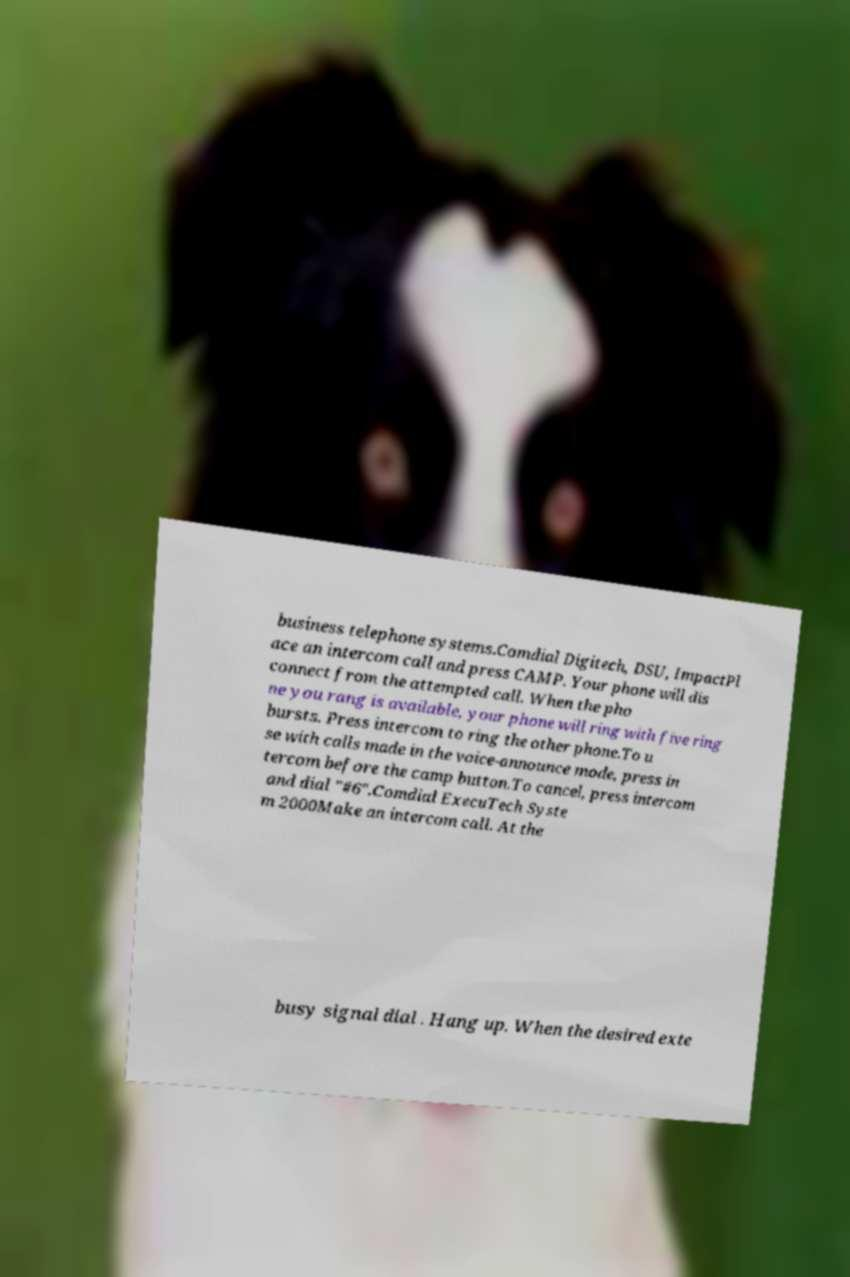There's text embedded in this image that I need extracted. Can you transcribe it verbatim? business telephone systems.Comdial Digitech, DSU, ImpactPl ace an intercom call and press CAMP. Your phone will dis connect from the attempted call. When the pho ne you rang is available, your phone will ring with five ring bursts. Press intercom to ring the other phone.To u se with calls made in the voice-announce mode, press in tercom before the camp button.To cancel, press intercom and dial "#6".Comdial ExecuTech Syste m 2000Make an intercom call. At the busy signal dial . Hang up. When the desired exte 